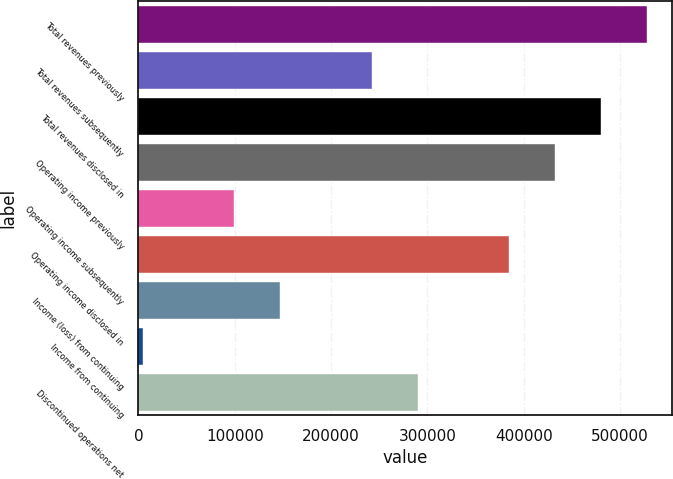<chart> <loc_0><loc_0><loc_500><loc_500><bar_chart><fcel>Total revenues previously<fcel>Total revenues subsequently<fcel>Total revenues disclosed in<fcel>Operating income previously<fcel>Operating income subsequently<fcel>Operating income disclosed in<fcel>Income (loss) from continuing<fcel>Income from continuing<fcel>Discontinued operations net<nl><fcel>527914<fcel>242430<fcel>480333<fcel>432752<fcel>99687.4<fcel>385172<fcel>147268<fcel>4526<fcel>290010<nl></chart> 